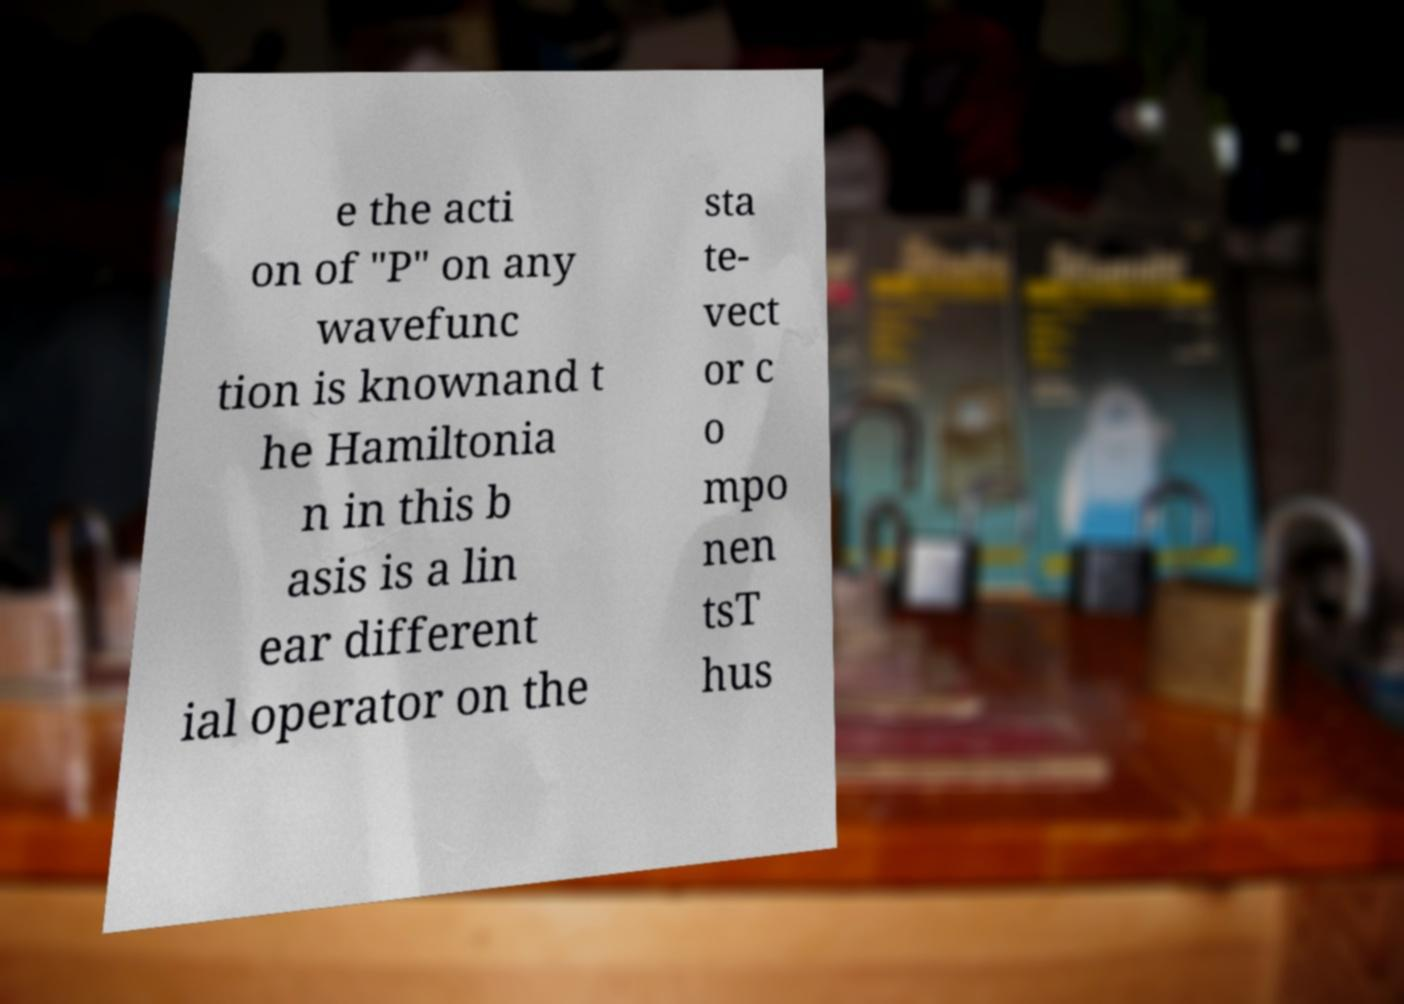What messages or text are displayed in this image? I need them in a readable, typed format. e the acti on of "P" on any wavefunc tion is knownand t he Hamiltonia n in this b asis is a lin ear different ial operator on the sta te- vect or c o mpo nen tsT hus 